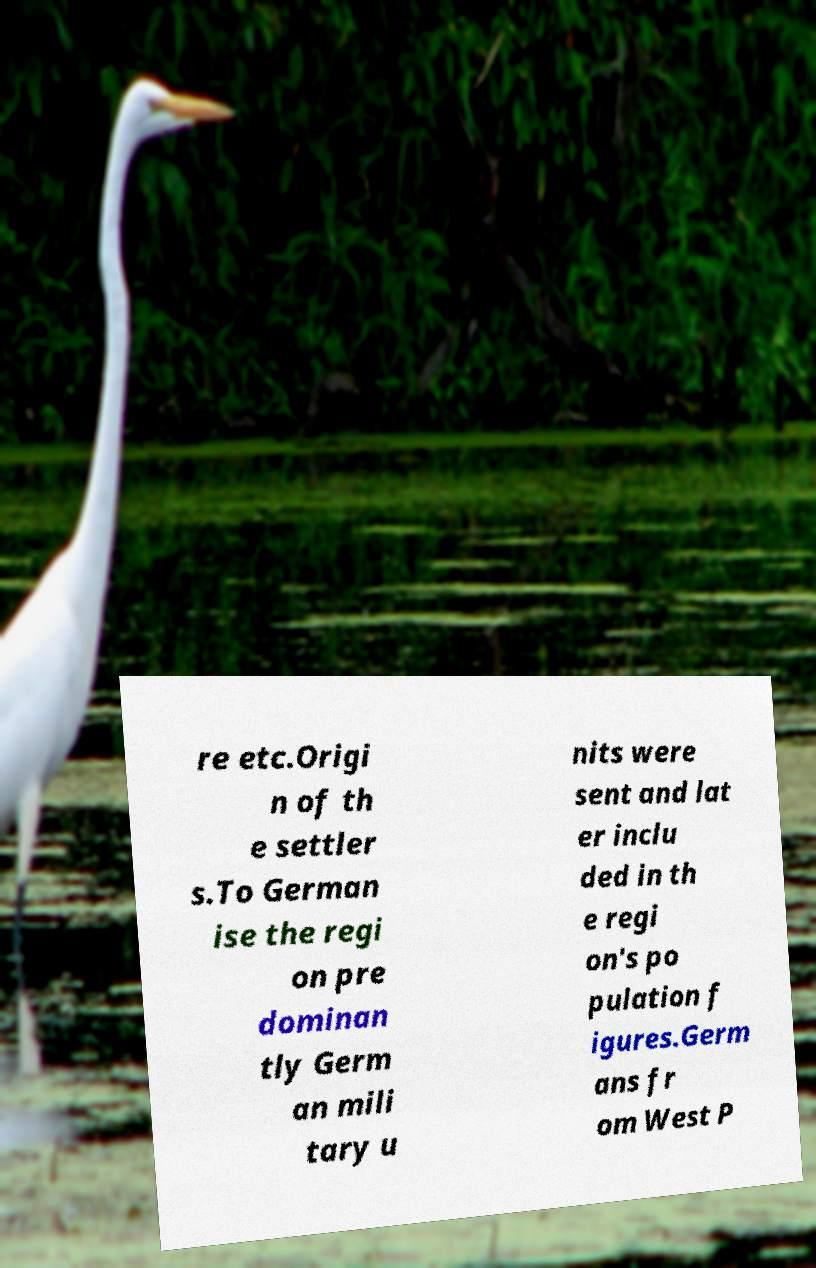Please identify and transcribe the text found in this image. re etc.Origi n of th e settler s.To German ise the regi on pre dominan tly Germ an mili tary u nits were sent and lat er inclu ded in th e regi on's po pulation f igures.Germ ans fr om West P 